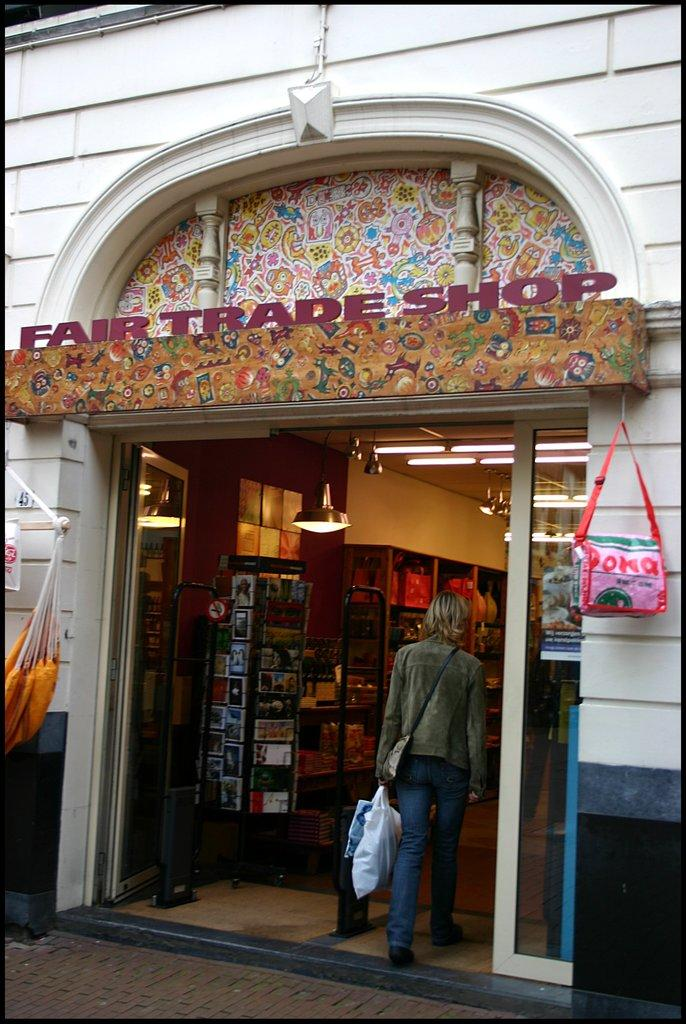What type of establishment is depicted in the image? There is a fair trade shop in the image. What is the woman in the image doing? A woman is entering the fair trade shop. Reasoning: Let' Let's think step by step in order to produce the conversation. We start by identifying the main subject of the image, which is the fair trade shop. Then, we describe the action of the woman in the image, who is entering the shop. We avoid asking questions that cannot be answered definitively with the information given and ensure that the language is simple and clear. Absurd Question/Answer: What type of coach can be seen in the image? There is no coach present in the image. What is the woman paying attention to as she enters the fair trade shop? The image does not provide information about what the woman is paying attention to attention to as she enters the shop. What type of jar can be seen on the shelf in the image? There is no jar present in the image. 